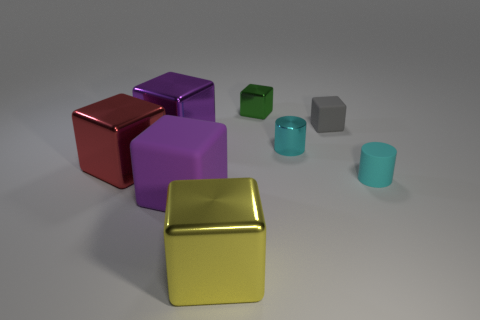Subtract all purple blocks. How many were subtracted if there are1purple blocks left? 1 Subtract all green blocks. How many blocks are left? 5 Subtract all red metal blocks. How many blocks are left? 5 Subtract all blue blocks. Subtract all yellow balls. How many blocks are left? 6 Add 1 small green shiny blocks. How many objects exist? 9 Subtract all cylinders. How many objects are left? 6 Add 8 tiny gray cubes. How many tiny gray cubes exist? 9 Subtract 0 cyan balls. How many objects are left? 8 Subtract all big purple matte blocks. Subtract all tiny cylinders. How many objects are left? 5 Add 8 small rubber objects. How many small rubber objects are left? 10 